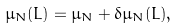Convert formula to latex. <formula><loc_0><loc_0><loc_500><loc_500>\mu _ { N } ( L ) = \mu _ { N } + \delta \mu _ { N } ( L ) ,</formula> 